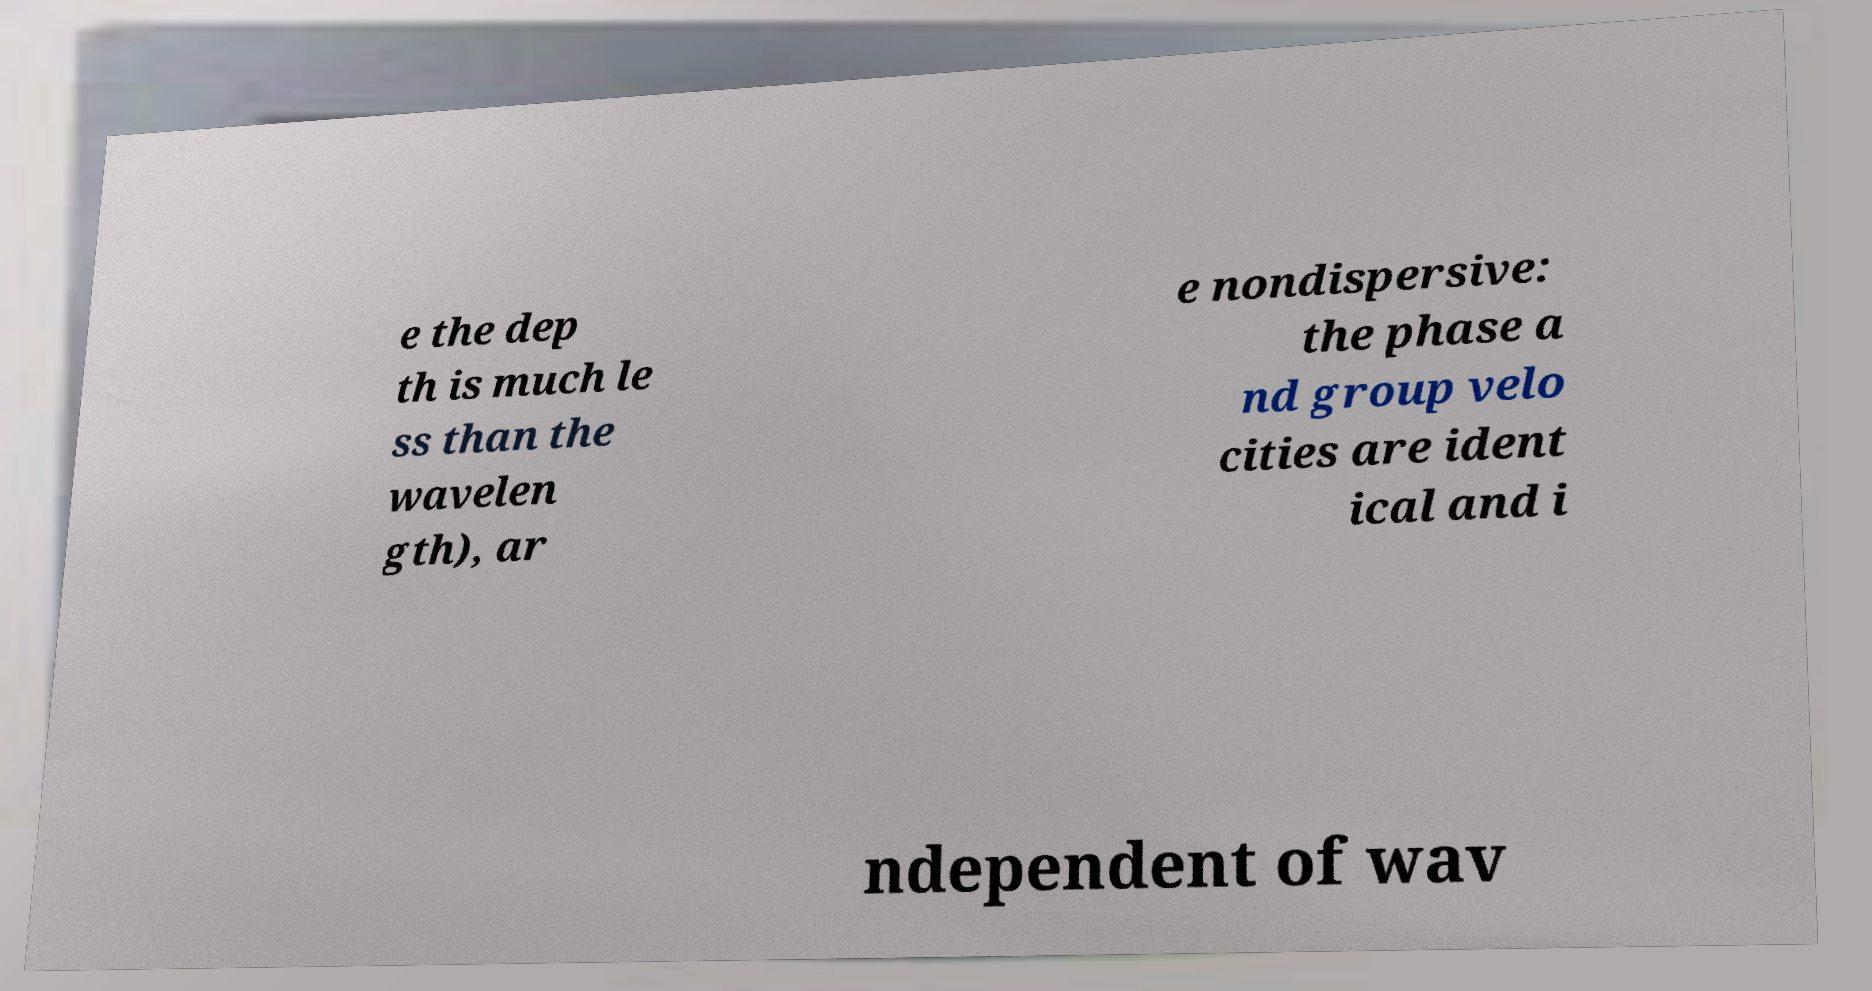Please identify and transcribe the text found in this image. e the dep th is much le ss than the wavelen gth), ar e nondispersive: the phase a nd group velo cities are ident ical and i ndependent of wav 